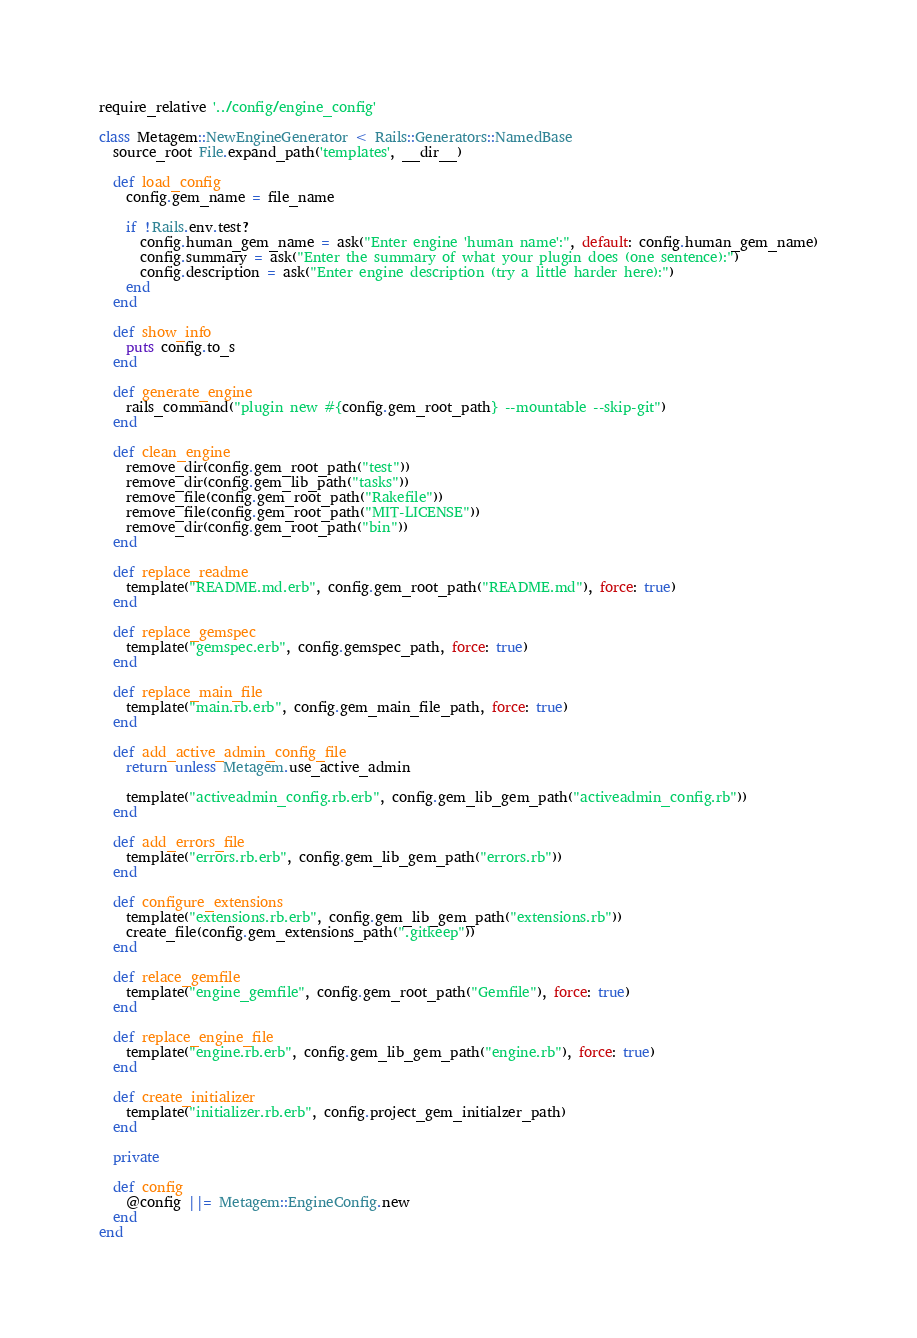<code> <loc_0><loc_0><loc_500><loc_500><_Ruby_>require_relative '../config/engine_config'

class Metagem::NewEngineGenerator < Rails::Generators::NamedBase
  source_root File.expand_path('templates', __dir__)

  def load_config
    config.gem_name = file_name

    if !Rails.env.test?
      config.human_gem_name = ask("Enter engine 'human name':", default: config.human_gem_name)
      config.summary = ask("Enter the summary of what your plugin does (one sentence):")
      config.description = ask("Enter engine description (try a little harder here):")
    end
  end

  def show_info
    puts config.to_s
  end

  def generate_engine
    rails_command("plugin new #{config.gem_root_path} --mountable --skip-git")
  end

  def clean_engine
    remove_dir(config.gem_root_path("test"))
    remove_dir(config.gem_lib_path("tasks"))
    remove_file(config.gem_root_path("Rakefile"))
    remove_file(config.gem_root_path("MIT-LICENSE"))
    remove_dir(config.gem_root_path("bin"))
  end

  def replace_readme
    template("README.md.erb", config.gem_root_path("README.md"), force: true)
  end

  def replace_gemspec
    template("gemspec.erb", config.gemspec_path, force: true)
  end

  def replace_main_file
    template("main.rb.erb", config.gem_main_file_path, force: true)
  end

  def add_active_admin_config_file
    return unless Metagem.use_active_admin

    template("activeadmin_config.rb.erb", config.gem_lib_gem_path("activeadmin_config.rb"))
  end

  def add_errors_file
    template("errors.rb.erb", config.gem_lib_gem_path("errors.rb"))
  end

  def configure_extensions
    template("extensions.rb.erb", config.gem_lib_gem_path("extensions.rb"))
    create_file(config.gem_extensions_path(".gitkeep"))
  end

  def relace_gemfile
    template("engine_gemfile", config.gem_root_path("Gemfile"), force: true)
  end

  def replace_engine_file
    template("engine.rb.erb", config.gem_lib_gem_path("engine.rb"), force: true)
  end

  def create_initializer
    template("initializer.rb.erb", config.project_gem_initialzer_path)
  end

  private

  def config
    @config ||= Metagem::EngineConfig.new
  end
end
</code> 